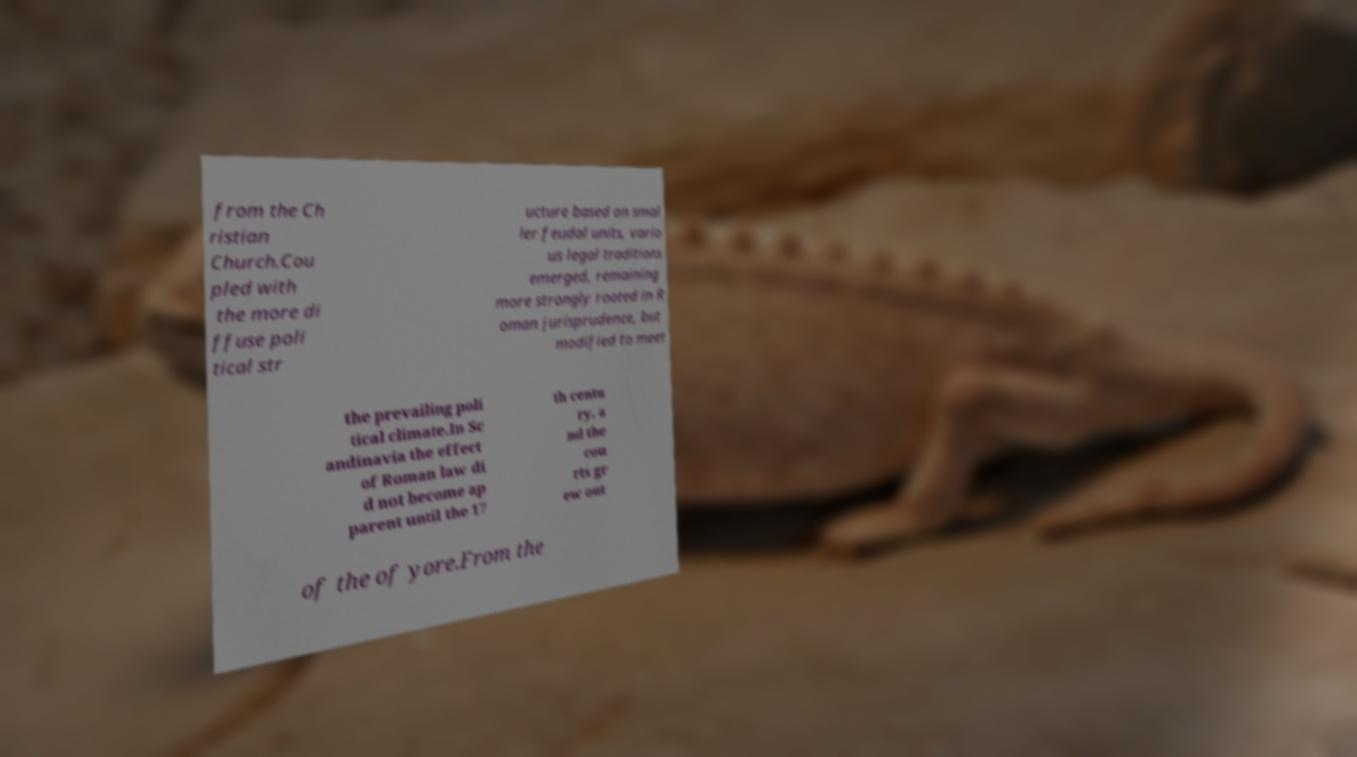Can you read and provide the text displayed in the image?This photo seems to have some interesting text. Can you extract and type it out for me? from the Ch ristian Church.Cou pled with the more di ffuse poli tical str ucture based on smal ler feudal units, vario us legal traditions emerged, remaining more strongly rooted in R oman jurisprudence, but modified to meet the prevailing poli tical climate.In Sc andinavia the effect of Roman law di d not become ap parent until the 17 th centu ry, a nd the cou rts gr ew out of the of yore.From the 